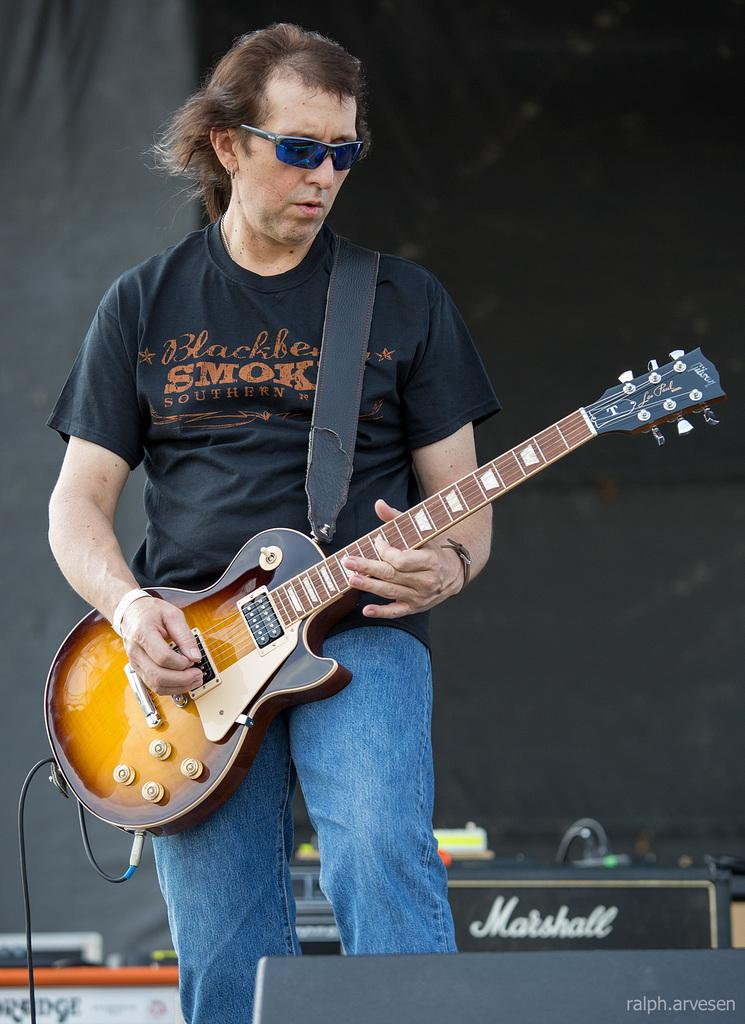What is the man in the image doing? The man in the image is playing a guitar. What accessory is the man wearing in the image? The man is wearing goggles. What type of riddle can be seen on the guitar in the image? There is no riddle present on the guitar in the image; the man is simply playing the guitar. How many frogs are visible in the image? There are no frogs present in the image. 